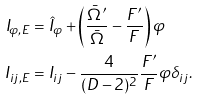Convert formula to latex. <formula><loc_0><loc_0><loc_500><loc_500>I _ { \varphi , E } & = \hat { I } _ { \varphi } + \left ( \frac { \bar { \Omega } ^ { \prime } } { \bar { \Omega } } - \frac { F ^ { \prime } } { F } \right ) \varphi \\ I _ { i j , E } & = I _ { i j } - \frac { 4 } { ( D - 2 ) ^ { 2 } } \frac { F ^ { \prime } } { F } \varphi \delta _ { i j } .</formula> 